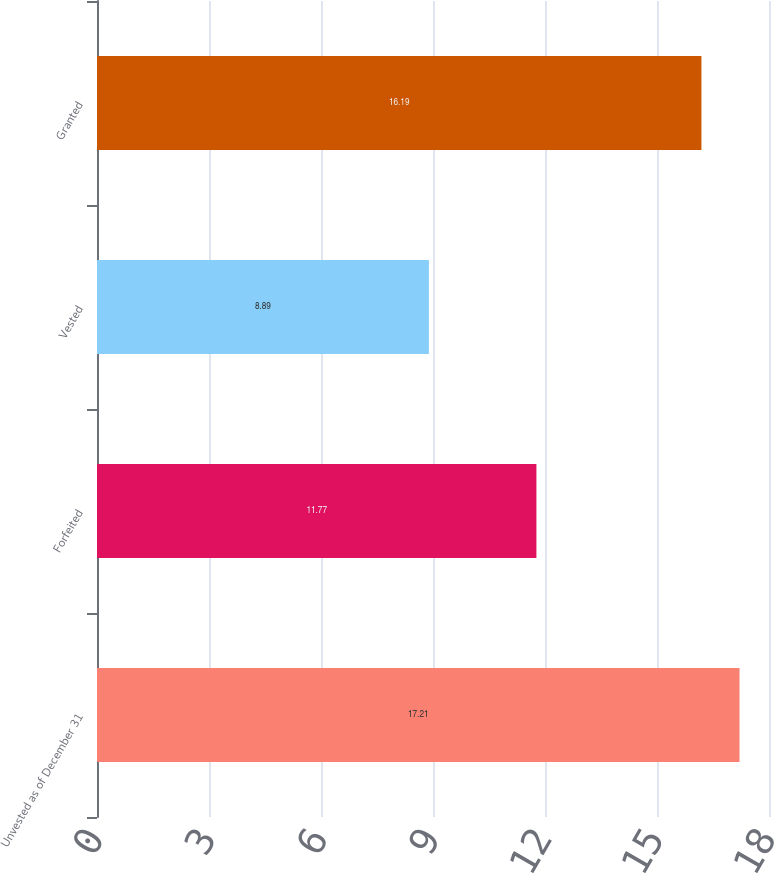Convert chart. <chart><loc_0><loc_0><loc_500><loc_500><bar_chart><fcel>Unvested as of December 31<fcel>Forfeited<fcel>Vested<fcel>Granted<nl><fcel>17.21<fcel>11.77<fcel>8.89<fcel>16.19<nl></chart> 